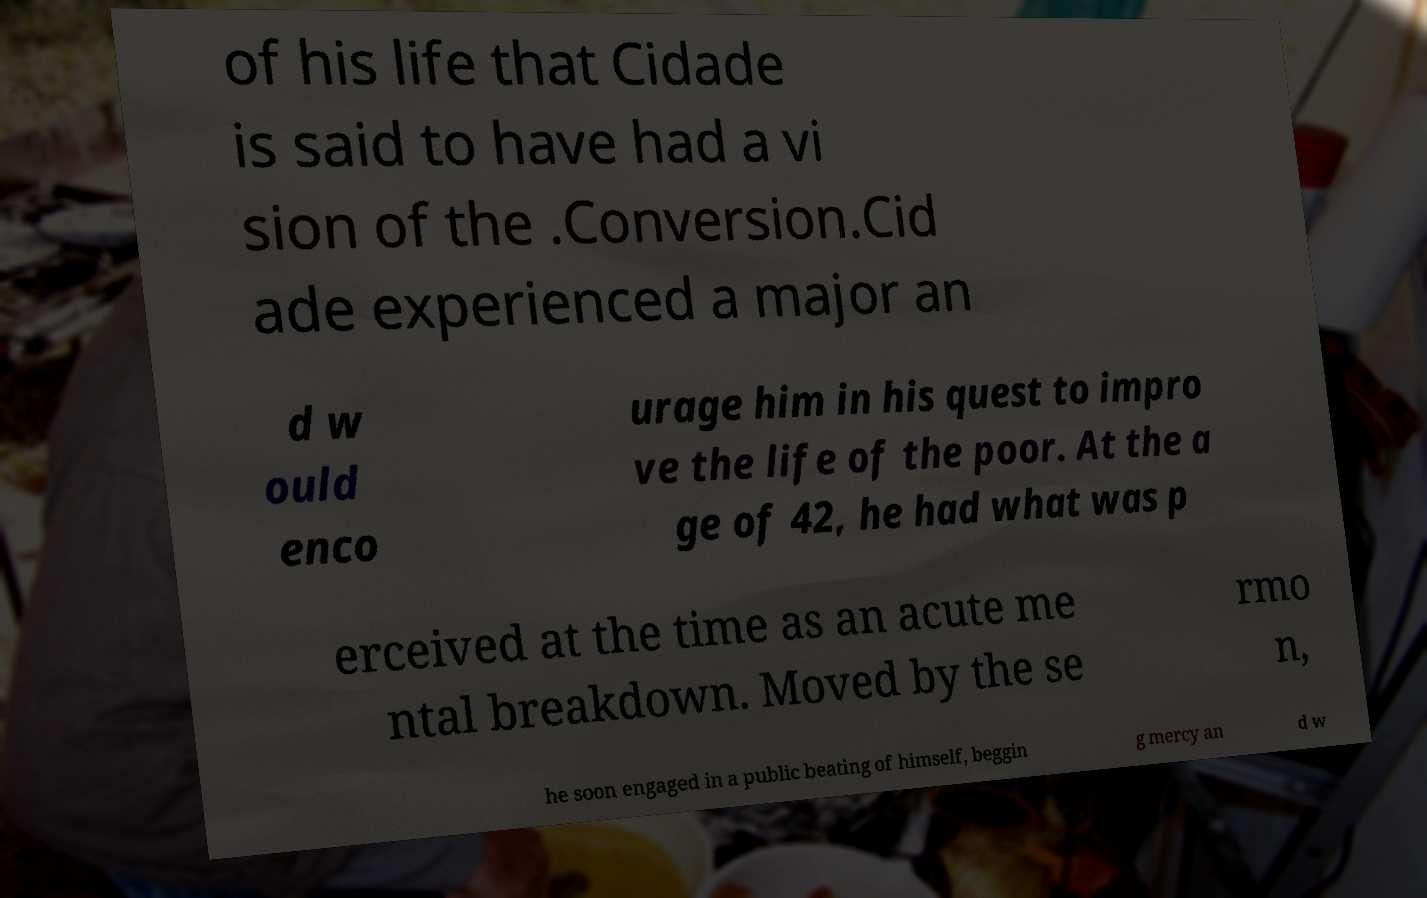Please identify and transcribe the text found in this image. of his life that Cidade is said to have had a vi sion of the .Conversion.Cid ade experienced a major an d w ould enco urage him in his quest to impro ve the life of the poor. At the a ge of 42, he had what was p erceived at the time as an acute me ntal breakdown. Moved by the se rmo n, he soon engaged in a public beating of himself, beggin g mercy an d w 